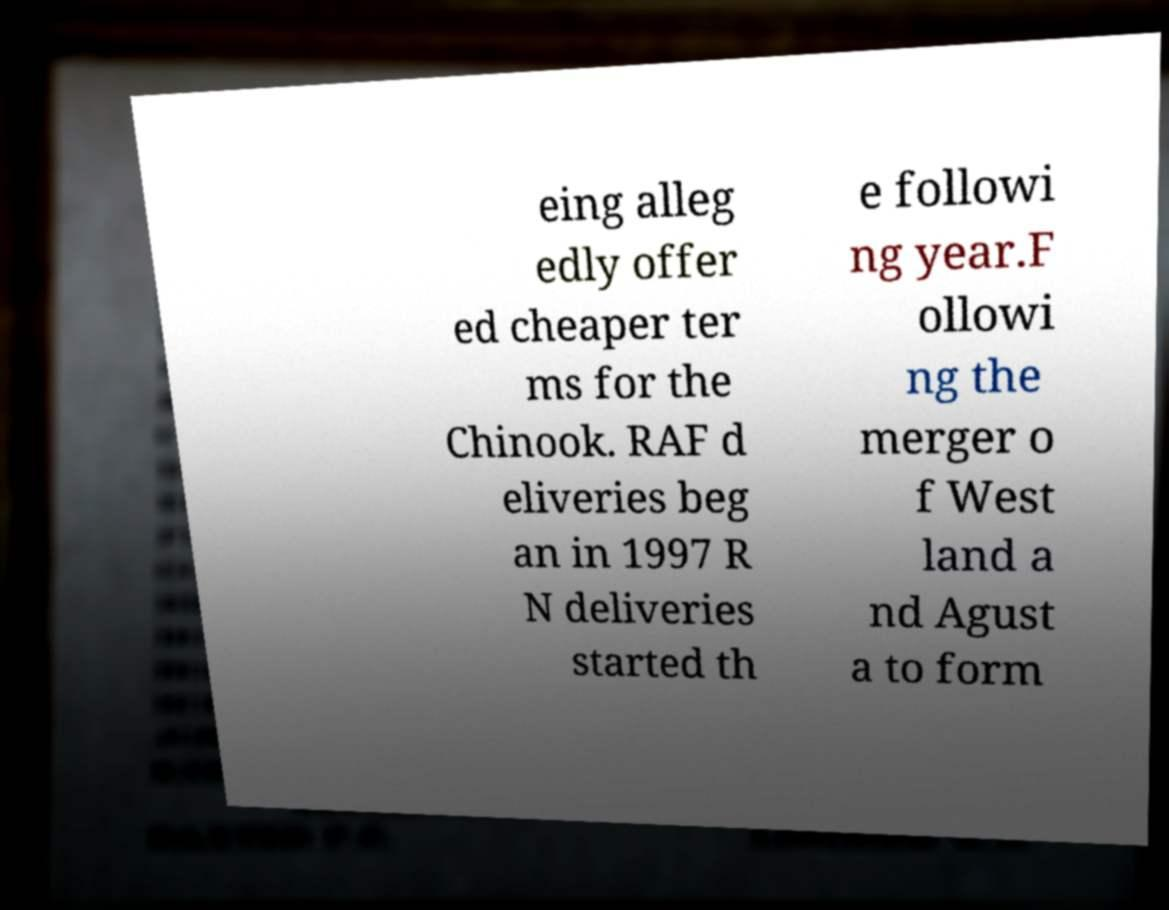Please read and relay the text visible in this image. What does it say? eing alleg edly offer ed cheaper ter ms for the Chinook. RAF d eliveries beg an in 1997 R N deliveries started th e followi ng year.F ollowi ng the merger o f West land a nd Agust a to form 